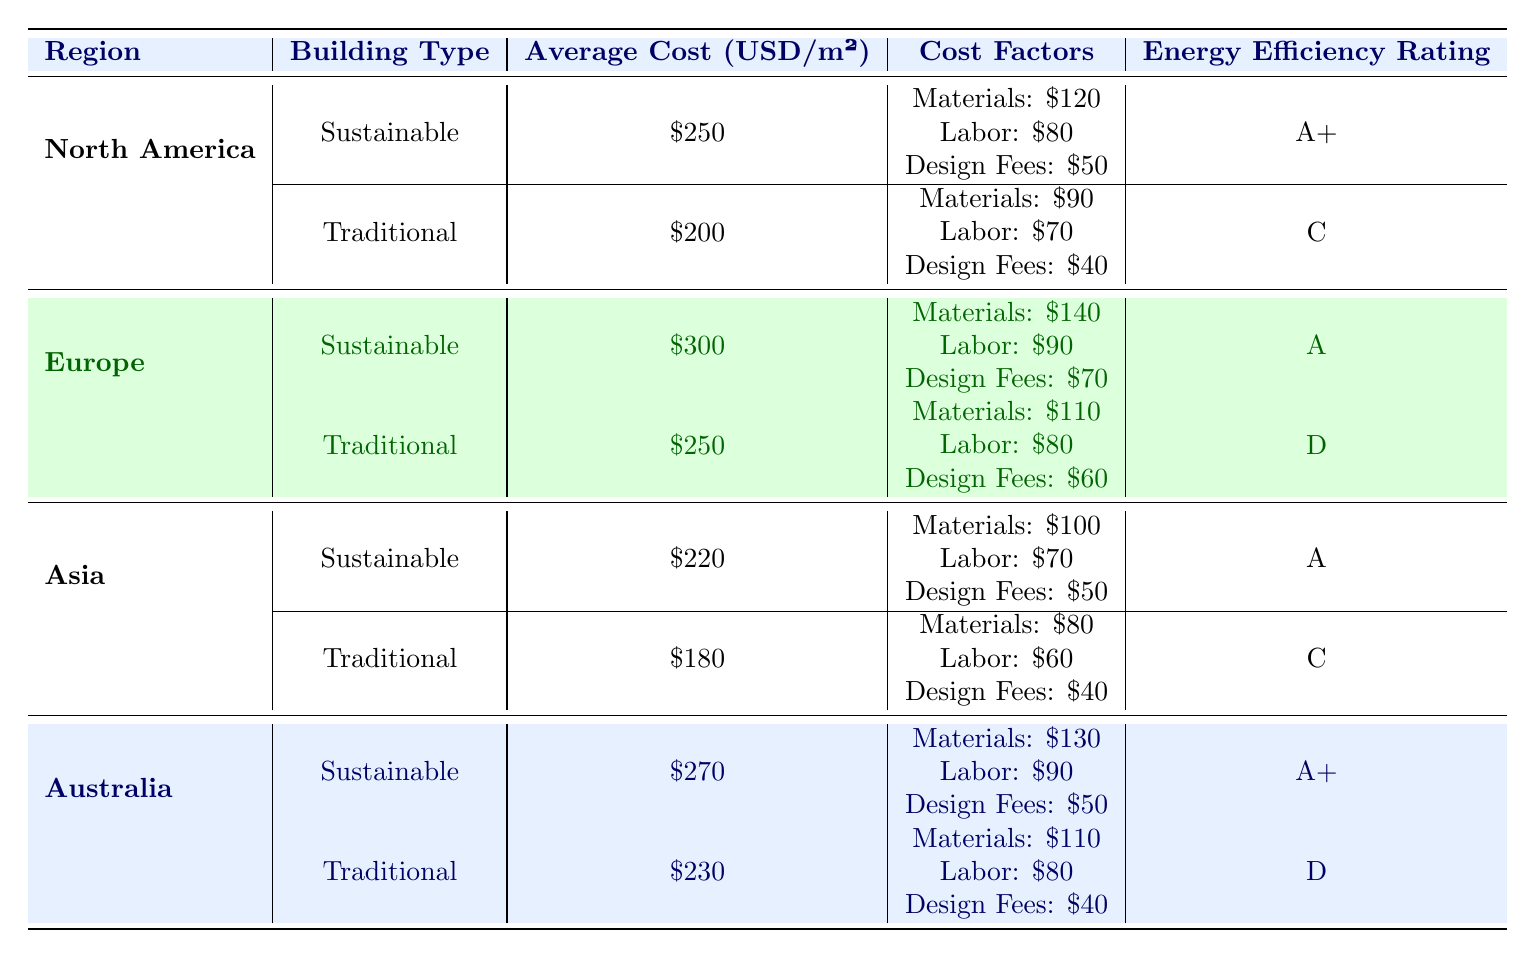What is the average cost per square meter for sustainable buildings in Asia? From the table, the average cost per square meter for sustainable buildings in Asia is listed as 220 USD/m².
Answer: 220 USD/m² Which building type has the highest average cost per square meter in Europe? In Europe, the sustainable building type has an average cost of 300 USD/m², while the traditional building type costs 250 USD/m². Thus, sustainable buildings have the highest average cost.
Answer: Sustainable Is the energy efficiency rating of the traditional building type in North America rated higher than that in Asia? The energy efficiency rating for the traditional building type in North America is 'C', while in Asia, it is also 'C', so they are equal.
Answer: No What is the total average cost per square meter for sustainable buildings across all regions? To find the total average cost, sum the average costs for sustainable buildings: 250 (North America) + 300 (Europe) + 220 (Asia) + 270 (Australia) = 1040 USD. Then, divide by 4 (total regions), which yields 260 USD/m².
Answer: 260 USD/m² Is the labor cost higher for traditional buildings in Australia than for sustainable buildings? The labor cost for traditional buildings in Australia is 80 USD, while for sustainable buildings, it's 90 USD. Thus, the labor cost for sustainable buildings is higher.
Answer: No Which region has the lowest average cost for traditional buildings? In the table, Asia has the lowest average cost for traditional buildings at 180 USD/m², compared to North America (200 USD/m²), Europe (250 USD/m²), and Australia (230 USD/m²).
Answer: Asia By how much do the average costs of sustainable buildings exceed those of traditional buildings in North America? The average cost of sustainable buildings in North America is 250 USD/m², and that of traditional buildings is 200 USD/m². The difference is 250 - 200 = 50 USD/m².
Answer: 50 USD/m² What is the energy efficiency rating for the sustainable building type in Australia? The table shows that the energy efficiency rating for the sustainable building type in Australia is 'A+'.
Answer: A+ 